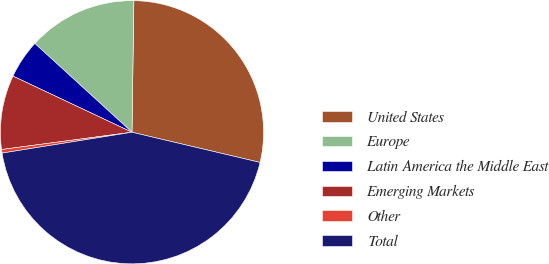Convert chart. <chart><loc_0><loc_0><loc_500><loc_500><pie_chart><fcel>United States<fcel>Europe<fcel>Latin America the Middle East<fcel>Emerging Markets<fcel>Other<fcel>Total<nl><fcel>28.46%<fcel>13.44%<fcel>4.77%<fcel>9.11%<fcel>0.44%<fcel>43.78%<nl></chart> 